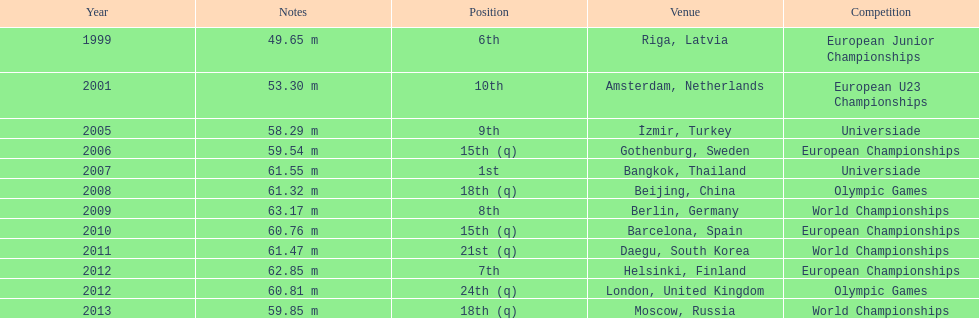What was mayer's best result: i.e his longest throw? 63.17 m. 